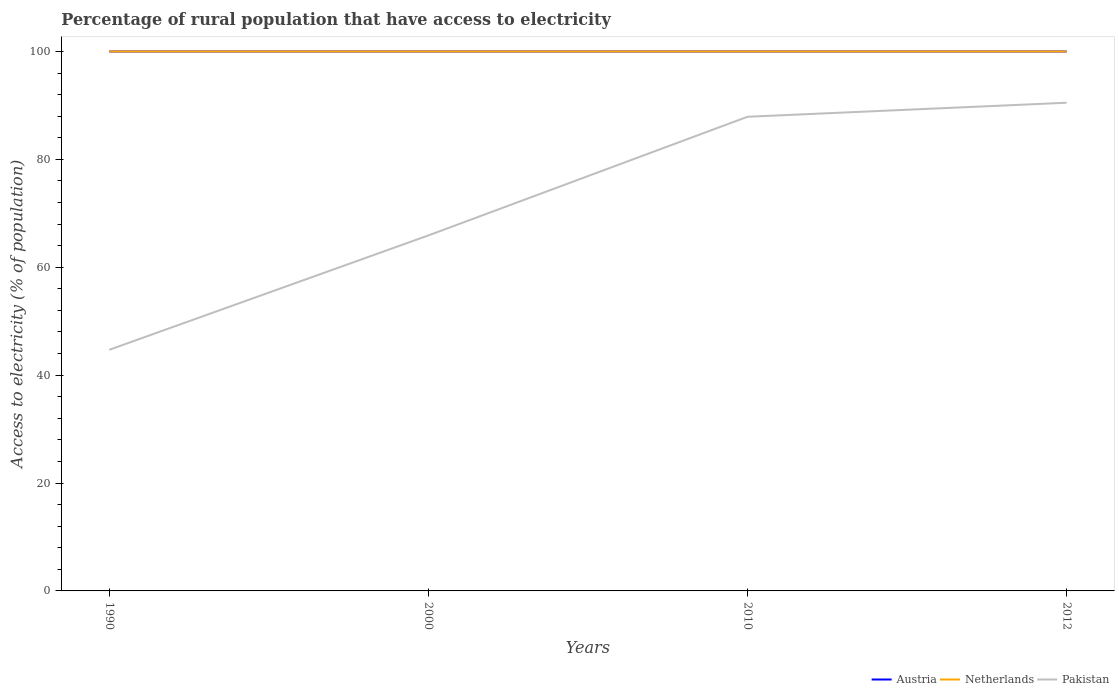Is the number of lines equal to the number of legend labels?
Provide a succinct answer. Yes. Across all years, what is the maximum percentage of rural population that have access to electricity in Pakistan?
Your answer should be compact. 44.7. In which year was the percentage of rural population that have access to electricity in Pakistan maximum?
Ensure brevity in your answer.  1990. What is the total percentage of rural population that have access to electricity in Pakistan in the graph?
Ensure brevity in your answer.  -22. What is the difference between the highest and the second highest percentage of rural population that have access to electricity in Austria?
Offer a very short reply. 0. Is the percentage of rural population that have access to electricity in Pakistan strictly greater than the percentage of rural population that have access to electricity in Austria over the years?
Make the answer very short. Yes. What is the difference between two consecutive major ticks on the Y-axis?
Your response must be concise. 20. Are the values on the major ticks of Y-axis written in scientific E-notation?
Your answer should be very brief. No. Does the graph contain any zero values?
Ensure brevity in your answer.  No. How many legend labels are there?
Your response must be concise. 3. What is the title of the graph?
Your answer should be compact. Percentage of rural population that have access to electricity. What is the label or title of the X-axis?
Offer a very short reply. Years. What is the label or title of the Y-axis?
Keep it short and to the point. Access to electricity (% of population). What is the Access to electricity (% of population) of Austria in 1990?
Keep it short and to the point. 100. What is the Access to electricity (% of population) in Pakistan in 1990?
Keep it short and to the point. 44.7. What is the Access to electricity (% of population) in Austria in 2000?
Make the answer very short. 100. What is the Access to electricity (% of population) in Pakistan in 2000?
Keep it short and to the point. 65.9. What is the Access to electricity (% of population) in Austria in 2010?
Your response must be concise. 100. What is the Access to electricity (% of population) of Netherlands in 2010?
Offer a very short reply. 100. What is the Access to electricity (% of population) in Pakistan in 2010?
Make the answer very short. 87.9. What is the Access to electricity (% of population) in Austria in 2012?
Offer a very short reply. 100. What is the Access to electricity (% of population) of Pakistan in 2012?
Offer a very short reply. 90.5. Across all years, what is the maximum Access to electricity (% of population) in Austria?
Offer a terse response. 100. Across all years, what is the maximum Access to electricity (% of population) in Pakistan?
Make the answer very short. 90.5. Across all years, what is the minimum Access to electricity (% of population) in Pakistan?
Provide a short and direct response. 44.7. What is the total Access to electricity (% of population) of Austria in the graph?
Offer a very short reply. 400. What is the total Access to electricity (% of population) in Netherlands in the graph?
Keep it short and to the point. 400. What is the total Access to electricity (% of population) of Pakistan in the graph?
Offer a terse response. 289. What is the difference between the Access to electricity (% of population) in Pakistan in 1990 and that in 2000?
Provide a succinct answer. -21.2. What is the difference between the Access to electricity (% of population) of Netherlands in 1990 and that in 2010?
Keep it short and to the point. 0. What is the difference between the Access to electricity (% of population) in Pakistan in 1990 and that in 2010?
Keep it short and to the point. -43.2. What is the difference between the Access to electricity (% of population) of Austria in 1990 and that in 2012?
Provide a short and direct response. 0. What is the difference between the Access to electricity (% of population) of Netherlands in 1990 and that in 2012?
Keep it short and to the point. 0. What is the difference between the Access to electricity (% of population) of Pakistan in 1990 and that in 2012?
Ensure brevity in your answer.  -45.8. What is the difference between the Access to electricity (% of population) in Austria in 2000 and that in 2010?
Your response must be concise. 0. What is the difference between the Access to electricity (% of population) of Netherlands in 2000 and that in 2010?
Offer a very short reply. 0. What is the difference between the Access to electricity (% of population) in Pakistan in 2000 and that in 2010?
Give a very brief answer. -22. What is the difference between the Access to electricity (% of population) in Austria in 2000 and that in 2012?
Offer a very short reply. 0. What is the difference between the Access to electricity (% of population) in Pakistan in 2000 and that in 2012?
Offer a very short reply. -24.6. What is the difference between the Access to electricity (% of population) of Austria in 2010 and that in 2012?
Offer a very short reply. 0. What is the difference between the Access to electricity (% of population) in Pakistan in 2010 and that in 2012?
Offer a terse response. -2.6. What is the difference between the Access to electricity (% of population) of Austria in 1990 and the Access to electricity (% of population) of Pakistan in 2000?
Ensure brevity in your answer.  34.1. What is the difference between the Access to electricity (% of population) in Netherlands in 1990 and the Access to electricity (% of population) in Pakistan in 2000?
Provide a short and direct response. 34.1. What is the difference between the Access to electricity (% of population) of Austria in 1990 and the Access to electricity (% of population) of Netherlands in 2010?
Your response must be concise. 0. What is the difference between the Access to electricity (% of population) in Austria in 1990 and the Access to electricity (% of population) in Pakistan in 2012?
Your response must be concise. 9.5. What is the difference between the Access to electricity (% of population) of Austria in 2000 and the Access to electricity (% of population) of Pakistan in 2010?
Provide a short and direct response. 12.1. What is the difference between the Access to electricity (% of population) in Netherlands in 2000 and the Access to electricity (% of population) in Pakistan in 2010?
Make the answer very short. 12.1. What is the difference between the Access to electricity (% of population) in Austria in 2000 and the Access to electricity (% of population) in Netherlands in 2012?
Your answer should be compact. 0. What is the difference between the Access to electricity (% of population) of Austria in 2000 and the Access to electricity (% of population) of Pakistan in 2012?
Your response must be concise. 9.5. What is the difference between the Access to electricity (% of population) of Austria in 2010 and the Access to electricity (% of population) of Pakistan in 2012?
Provide a succinct answer. 9.5. What is the difference between the Access to electricity (% of population) in Netherlands in 2010 and the Access to electricity (% of population) in Pakistan in 2012?
Your answer should be very brief. 9.5. What is the average Access to electricity (% of population) in Netherlands per year?
Offer a very short reply. 100. What is the average Access to electricity (% of population) in Pakistan per year?
Keep it short and to the point. 72.25. In the year 1990, what is the difference between the Access to electricity (% of population) in Austria and Access to electricity (% of population) in Pakistan?
Provide a succinct answer. 55.3. In the year 1990, what is the difference between the Access to electricity (% of population) of Netherlands and Access to electricity (% of population) of Pakistan?
Provide a succinct answer. 55.3. In the year 2000, what is the difference between the Access to electricity (% of population) of Austria and Access to electricity (% of population) of Netherlands?
Provide a short and direct response. 0. In the year 2000, what is the difference between the Access to electricity (% of population) of Austria and Access to electricity (% of population) of Pakistan?
Your answer should be compact. 34.1. In the year 2000, what is the difference between the Access to electricity (% of population) of Netherlands and Access to electricity (% of population) of Pakistan?
Your answer should be compact. 34.1. In the year 2010, what is the difference between the Access to electricity (% of population) of Austria and Access to electricity (% of population) of Pakistan?
Offer a very short reply. 12.1. In the year 2010, what is the difference between the Access to electricity (% of population) of Netherlands and Access to electricity (% of population) of Pakistan?
Your response must be concise. 12.1. What is the ratio of the Access to electricity (% of population) of Pakistan in 1990 to that in 2000?
Ensure brevity in your answer.  0.68. What is the ratio of the Access to electricity (% of population) in Pakistan in 1990 to that in 2010?
Your answer should be very brief. 0.51. What is the ratio of the Access to electricity (% of population) of Pakistan in 1990 to that in 2012?
Your response must be concise. 0.49. What is the ratio of the Access to electricity (% of population) of Austria in 2000 to that in 2010?
Your answer should be compact. 1. What is the ratio of the Access to electricity (% of population) of Pakistan in 2000 to that in 2010?
Keep it short and to the point. 0.75. What is the ratio of the Access to electricity (% of population) in Austria in 2000 to that in 2012?
Your response must be concise. 1. What is the ratio of the Access to electricity (% of population) in Pakistan in 2000 to that in 2012?
Ensure brevity in your answer.  0.73. What is the ratio of the Access to electricity (% of population) of Netherlands in 2010 to that in 2012?
Make the answer very short. 1. What is the ratio of the Access to electricity (% of population) of Pakistan in 2010 to that in 2012?
Your answer should be compact. 0.97. What is the difference between the highest and the second highest Access to electricity (% of population) in Austria?
Your response must be concise. 0. What is the difference between the highest and the second highest Access to electricity (% of population) of Netherlands?
Make the answer very short. 0. What is the difference between the highest and the second highest Access to electricity (% of population) in Pakistan?
Your response must be concise. 2.6. What is the difference between the highest and the lowest Access to electricity (% of population) in Austria?
Provide a succinct answer. 0. What is the difference between the highest and the lowest Access to electricity (% of population) in Netherlands?
Provide a succinct answer. 0. What is the difference between the highest and the lowest Access to electricity (% of population) of Pakistan?
Your answer should be very brief. 45.8. 